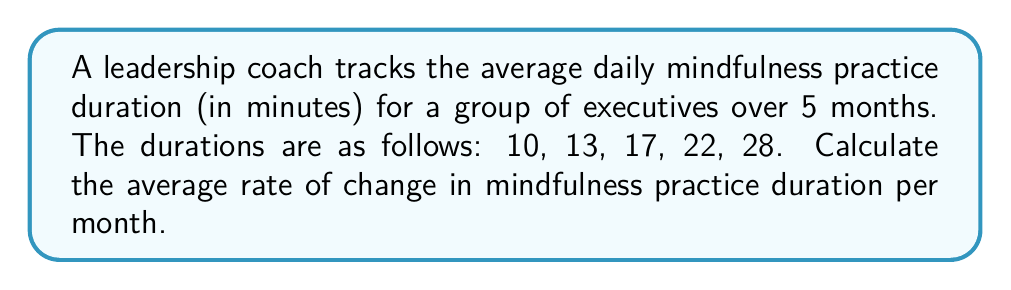Solve this math problem. To calculate the average rate of change, we need to follow these steps:

1. Identify the total change in mindfulness practice duration:
   Final value - Initial value = $28 - 10 = 18$ minutes

2. Determine the time period:
   5 months

3. Calculate the average rate of change using the formula:
   $$\text{Average rate of change} = \frac{\text{Total change}}{\text{Time period}}$$

4. Substitute the values:
   $$\text{Average rate of change} = \frac{18 \text{ minutes}}{5 \text{ months}}$$

5. Perform the division:
   $$\text{Average rate of change} = 3.6 \text{ minutes per month}$$

This result indicates that, on average, the mindfulness practice duration increased by 3.6 minutes each month over the 5-month period.
Answer: $3.6$ minutes/month 